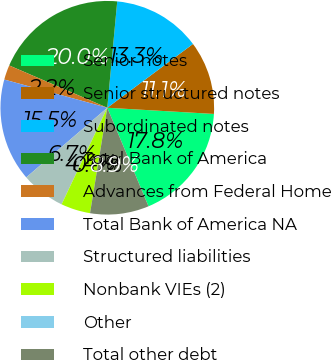Convert chart. <chart><loc_0><loc_0><loc_500><loc_500><pie_chart><fcel>Senior notes<fcel>Senior structured notes<fcel>Subordinated notes<fcel>Total Bank of America<fcel>Advances from Federal Home<fcel>Total Bank of America NA<fcel>Structured liabilities<fcel>Nonbank VIEs (2)<fcel>Other<fcel>Total other debt<nl><fcel>17.77%<fcel>11.11%<fcel>13.33%<fcel>20.0%<fcel>2.23%<fcel>15.55%<fcel>6.67%<fcel>4.45%<fcel>0.0%<fcel>8.89%<nl></chart> 